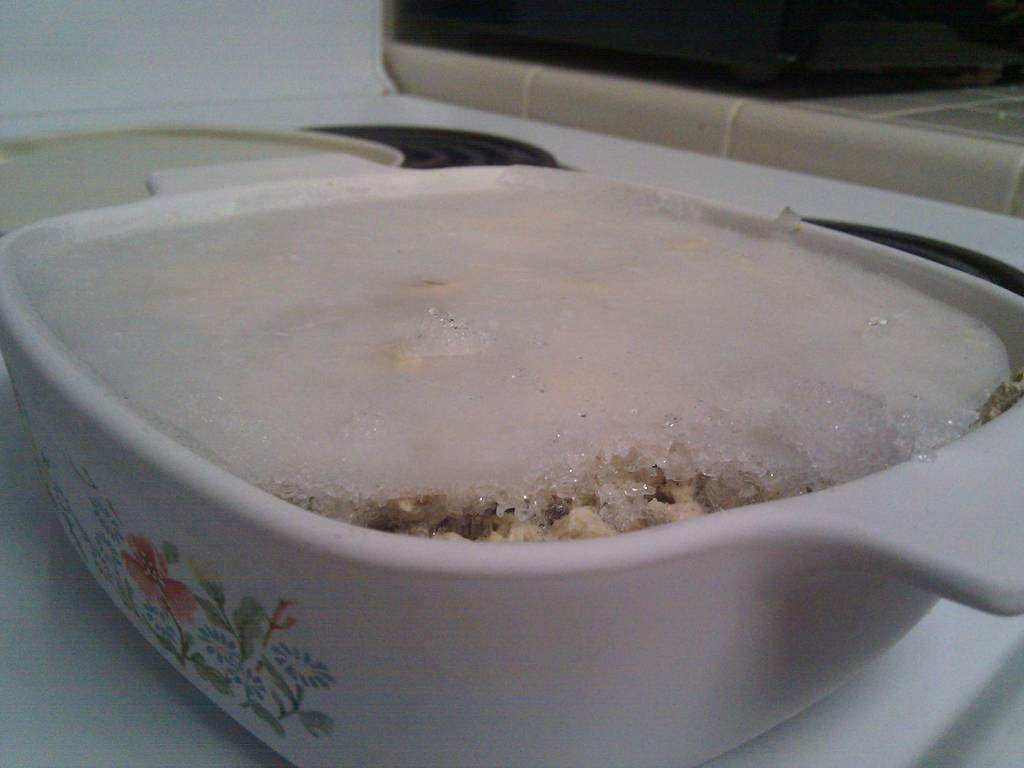What is located in the center of the image? There is a bowl in the center of the image. What is inside the bowl? The bowl contains a food item. What type of rice can be seen growing in the sea in the image? There is no rice or sea visible in the image; it only features a bowl in the center. 